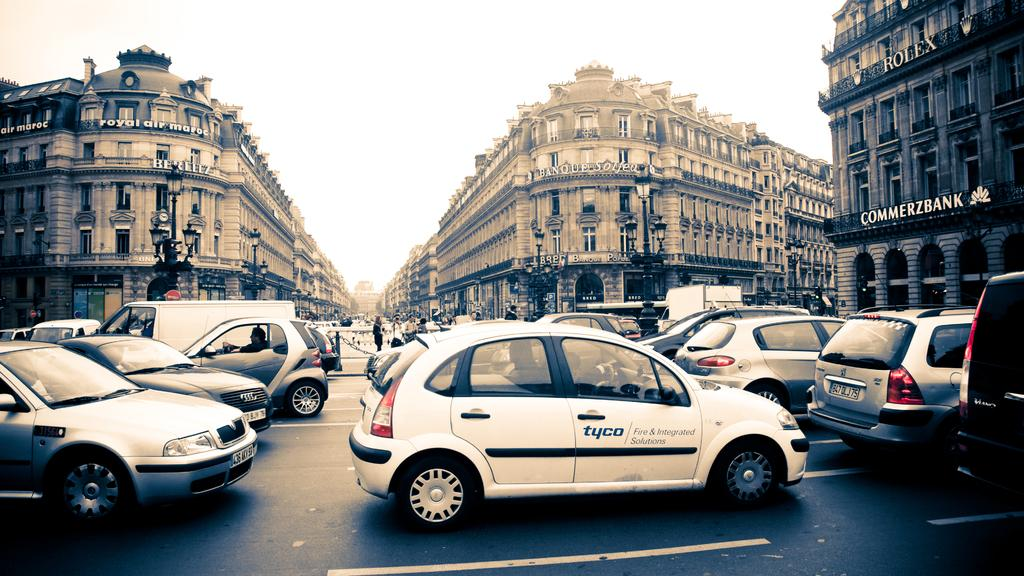<image>
Offer a succinct explanation of the picture presented. a tyco car that is on the street 